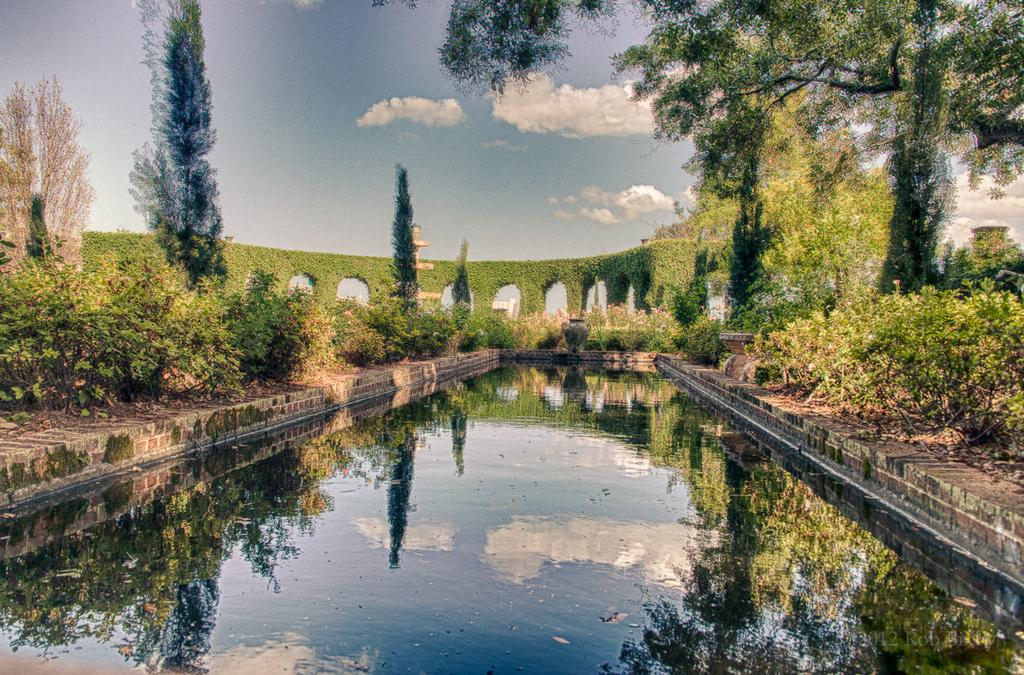What type of vegetation can be seen in the image? There are plants and trees in the image. What is growing on the wall in the image? There are creepers growing on the wall in the image. What is visible in the sky in the image? The sky is visible in the image, and there are clouds present. What can be seen at the bottom of the image? There is water visible at the bottom of the image. What type of wristwatch is the church wearing in the image? There is no church or wristwatch present in the image. What mathematical calculations can be performed using the calculator in the image? There is no calculator present in the image. 